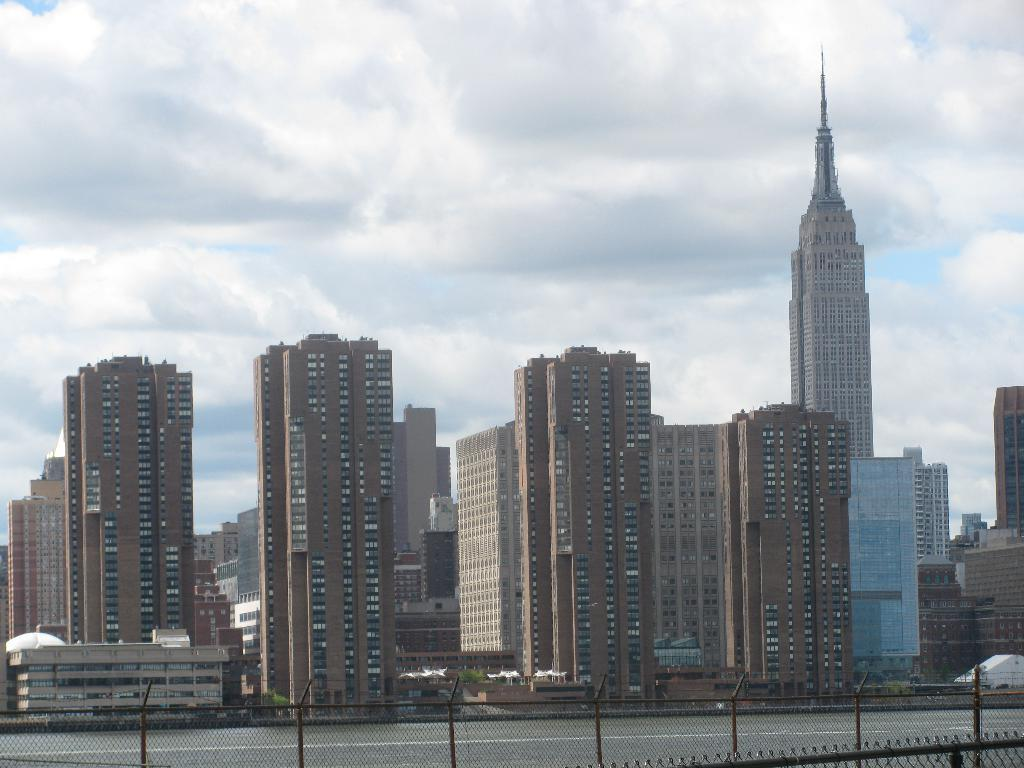What type of structures can be seen in the image? There are buildings in the image. What is separating the buildings from the road? There is: There is a fence in the image. What is the pathway for vehicles or pedestrians in the image? There is a road in the image. What is visible above the buildings and road? The sky is visible in the image. How would you describe the weather based on the appearance of the sky? The sky appears to be cloudy in the image. Where is the box that the beetle is ashamed of in the image? There is no box or beetle present in the image. What type of emotion is the beetle experiencing in the image? There is no beetle present in the image, so it cannot be determined what emotion it might be experiencing. 